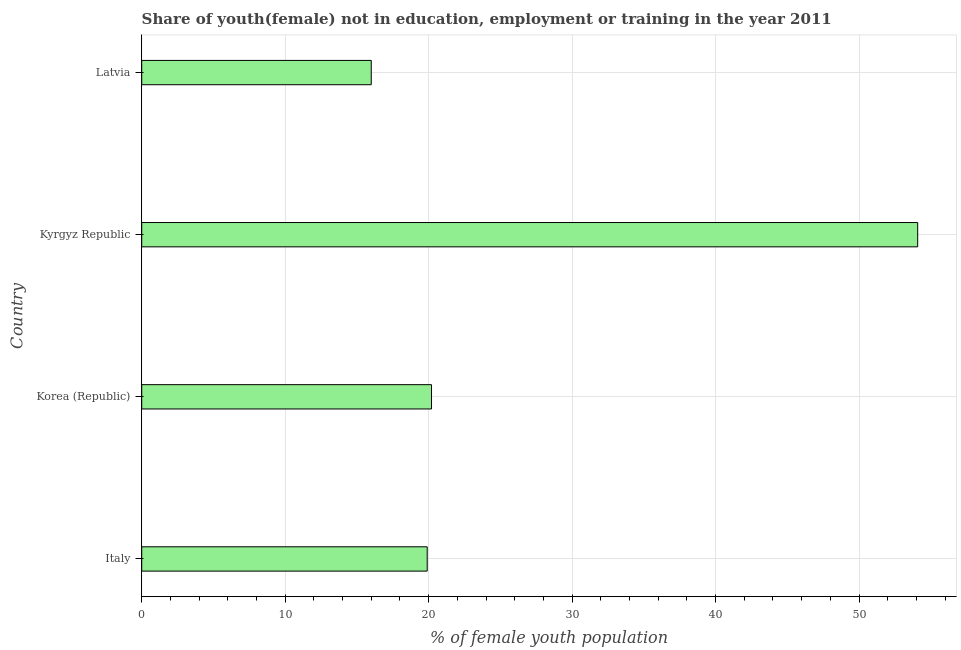Does the graph contain grids?
Offer a terse response. Yes. What is the title of the graph?
Give a very brief answer. Share of youth(female) not in education, employment or training in the year 2011. What is the label or title of the X-axis?
Make the answer very short. % of female youth population. Across all countries, what is the maximum unemployed female youth population?
Keep it short and to the point. 54.09. Across all countries, what is the minimum unemployed female youth population?
Offer a terse response. 16. In which country was the unemployed female youth population maximum?
Your answer should be compact. Kyrgyz Republic. In which country was the unemployed female youth population minimum?
Ensure brevity in your answer.  Latvia. What is the sum of the unemployed female youth population?
Offer a terse response. 110.19. What is the difference between the unemployed female youth population in Korea (Republic) and Latvia?
Ensure brevity in your answer.  4.2. What is the average unemployed female youth population per country?
Your answer should be very brief. 27.55. What is the median unemployed female youth population?
Keep it short and to the point. 20.05. What is the ratio of the unemployed female youth population in Italy to that in Kyrgyz Republic?
Give a very brief answer. 0.37. Is the unemployed female youth population in Korea (Republic) less than that in Kyrgyz Republic?
Provide a short and direct response. Yes. What is the difference between the highest and the second highest unemployed female youth population?
Your answer should be very brief. 33.89. Is the sum of the unemployed female youth population in Italy and Latvia greater than the maximum unemployed female youth population across all countries?
Your answer should be very brief. No. What is the difference between the highest and the lowest unemployed female youth population?
Keep it short and to the point. 38.09. In how many countries, is the unemployed female youth population greater than the average unemployed female youth population taken over all countries?
Offer a terse response. 1. What is the % of female youth population in Italy?
Offer a very short reply. 19.9. What is the % of female youth population of Korea (Republic)?
Offer a very short reply. 20.2. What is the % of female youth population in Kyrgyz Republic?
Provide a short and direct response. 54.09. What is the difference between the % of female youth population in Italy and Korea (Republic)?
Offer a very short reply. -0.3. What is the difference between the % of female youth population in Italy and Kyrgyz Republic?
Offer a very short reply. -34.19. What is the difference between the % of female youth population in Korea (Republic) and Kyrgyz Republic?
Your answer should be compact. -33.89. What is the difference between the % of female youth population in Kyrgyz Republic and Latvia?
Provide a succinct answer. 38.09. What is the ratio of the % of female youth population in Italy to that in Korea (Republic)?
Give a very brief answer. 0.98. What is the ratio of the % of female youth population in Italy to that in Kyrgyz Republic?
Offer a very short reply. 0.37. What is the ratio of the % of female youth population in Italy to that in Latvia?
Give a very brief answer. 1.24. What is the ratio of the % of female youth population in Korea (Republic) to that in Kyrgyz Republic?
Offer a very short reply. 0.37. What is the ratio of the % of female youth population in Korea (Republic) to that in Latvia?
Your answer should be compact. 1.26. What is the ratio of the % of female youth population in Kyrgyz Republic to that in Latvia?
Offer a very short reply. 3.38. 